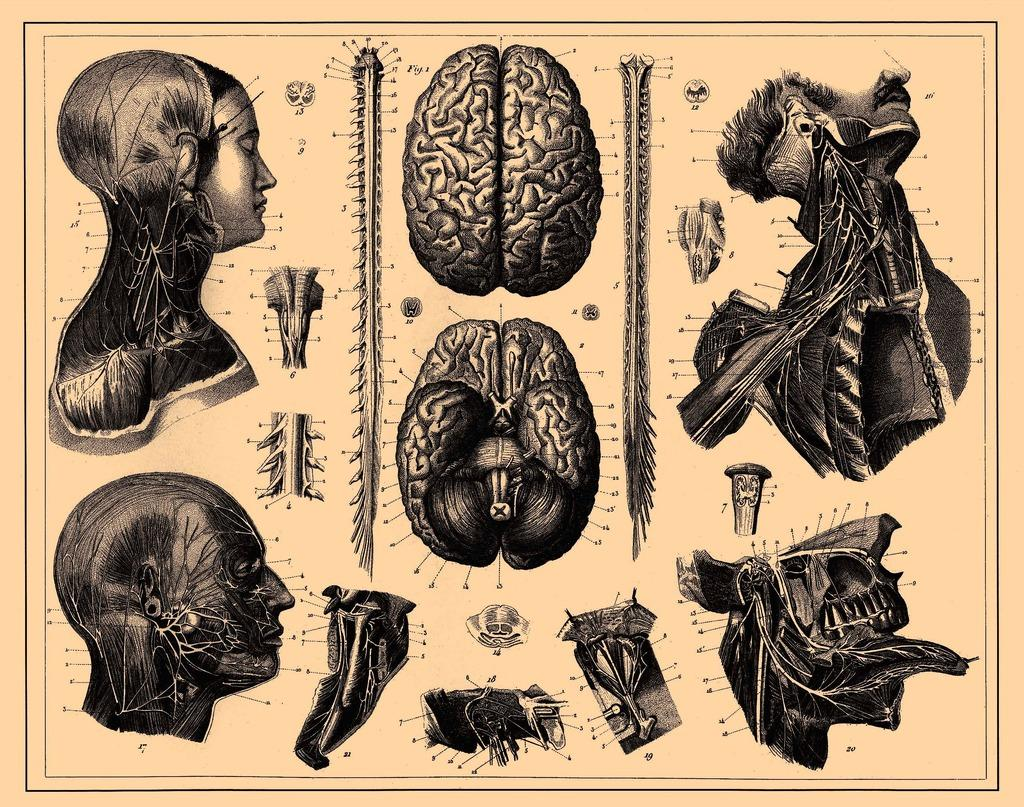What is the main focus of the image? The image contains depictions of the brain, skeletons, and other parts of the body. Can you describe the depictions of the brain in the image? The image contains depictions of the brain, but no specific details are provided. What other body parts are depicted in the image besides the brain and skeletons? The image contains depictions of other parts of the body, but no specific details are provided. How many steps are visible in the image? There are no steps present in the image; it contains depictions of the brain, skeletons, and other parts of the body. What type of wound can be seen on the frog in the image? There is no frog present in the image; it contains depictions of the brain, skeletons, and other parts of the body. 